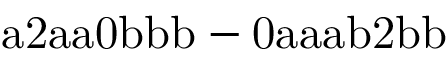<formula> <loc_0><loc_0><loc_500><loc_500>a 2 a a 0 b b b - 0 a a a b 2 b b</formula> 